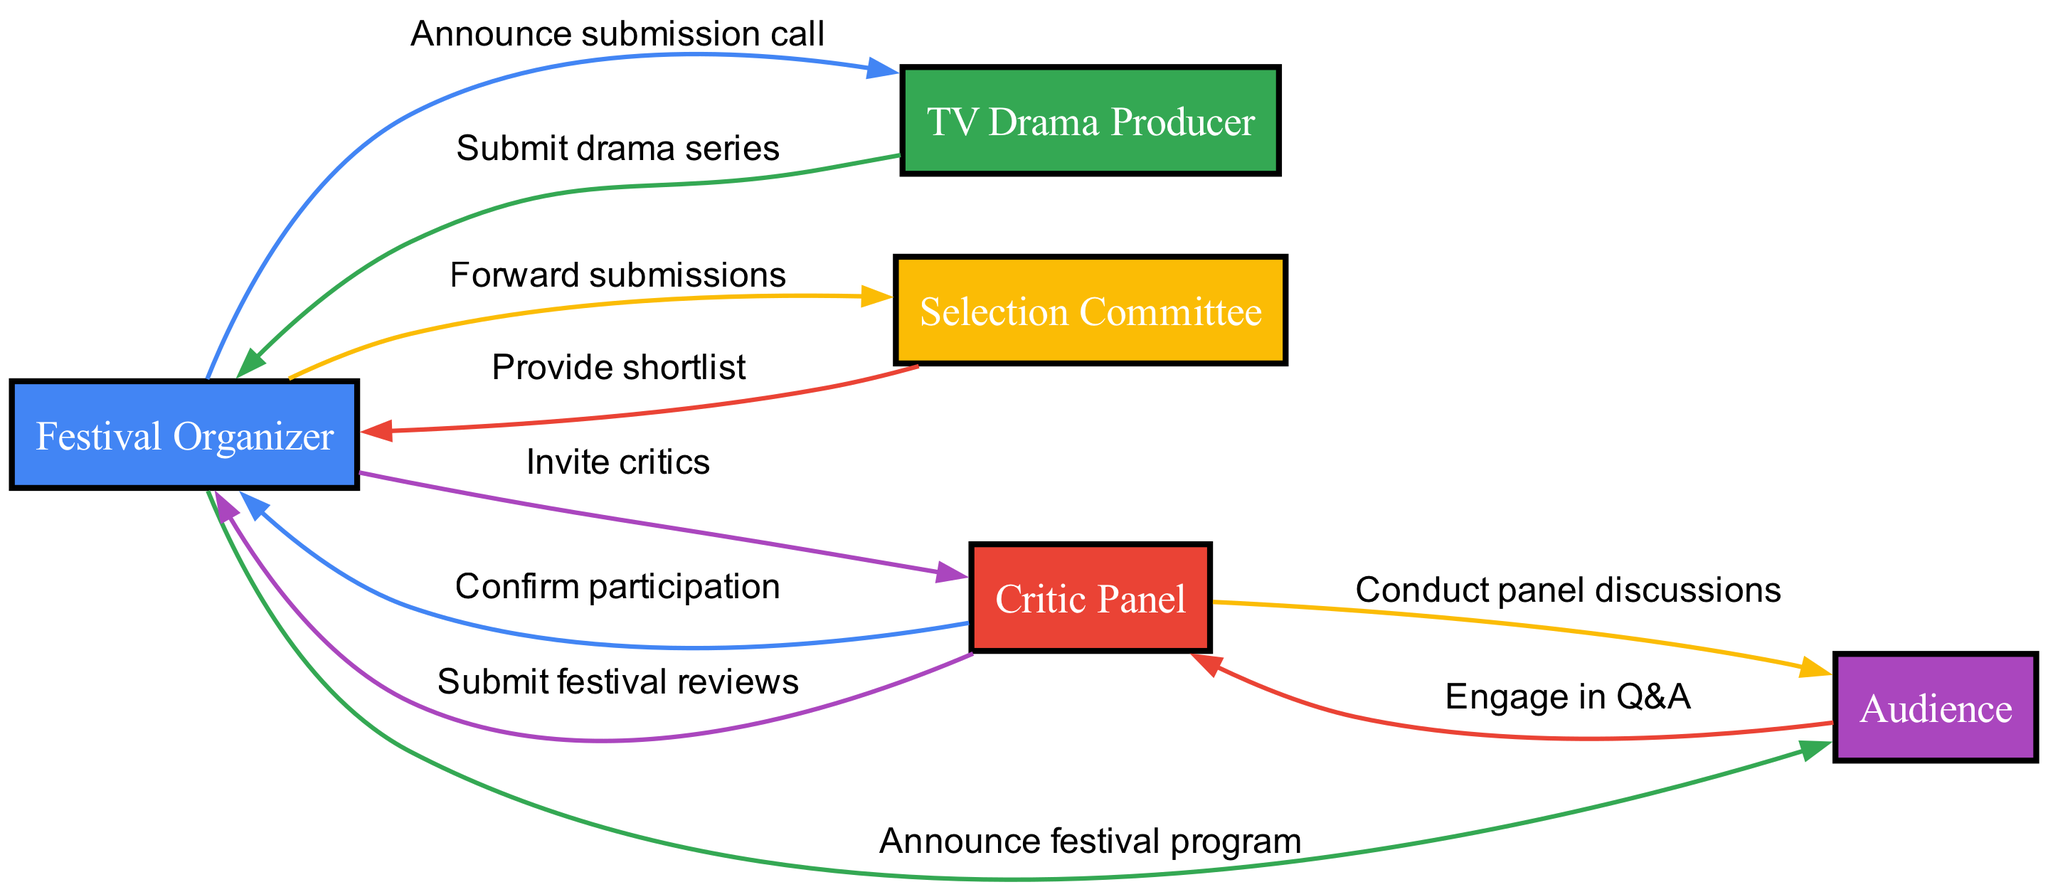What is the first action in the workflow? The first action is initiated by the Festival Organizer when they announce the submission call to TV Drama Producers.
Answer: Announce submission call Who confirms participation in the festival? The Critic Panel sends a confirmation of their participation to the Festival Organizer after being invited.
Answer: Confirm participation How many actors are involved in the diagram? There are five distinct actors depicted in the sequence diagram contributing to the workflow of the festival.
Answer: Five What action does the Selection Committee take after receiving submissions? After receiving submissions, the Selection Committee provides a shortlist back to the Festival Organizer.
Answer: Provide shortlist Which actor conducts panel discussions? The Critic Panel engages with the Audience by conducting panel discussions during the festival.
Answer: Conduct panel discussions What is the final action taken by the Critic Panel in the workflow? The final action taken by the Critic Panel is to submit festival reviews to the Festival Organizer at the end of the event.
Answer: Submit festival reviews What do Audience members engage in with the Critic Panel? Audience members participate in a Q&A session with the Critic Panel after the discussions.
Answer: Engage in Q&A Which actor receives the festival program announcement? The Audience is the recipient of the information regarding the festival program announced by the Festival Organizer.
Answer: Audience 